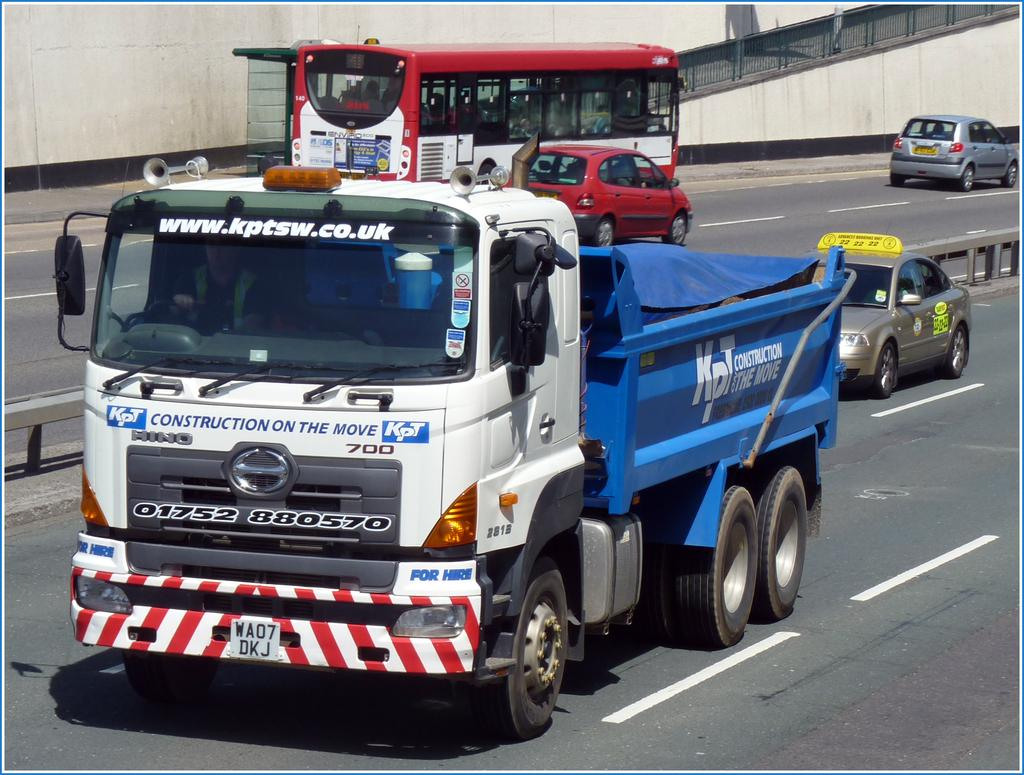Provide a one-sentence caption for the provided image. The dump truck is from the United Kingdom and has a blue bed. 